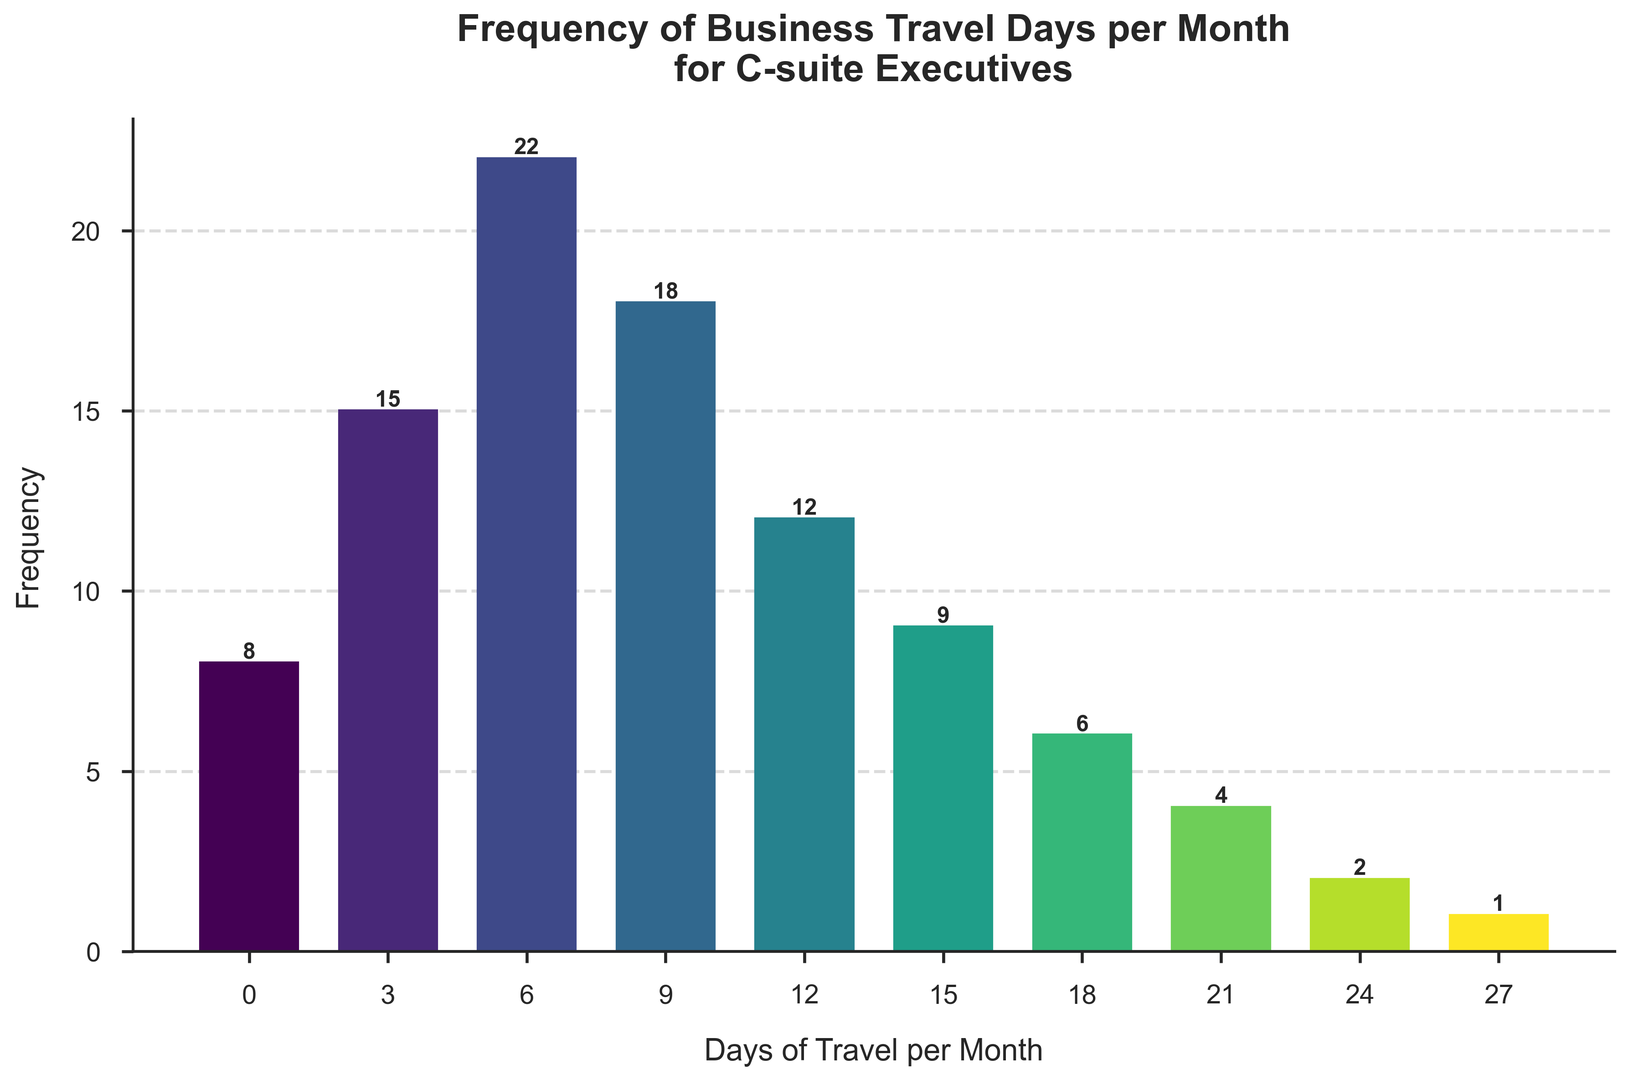What range of days has the highest frequency of business travel? By looking at the height of the bars, the "6-8" range has the tallest bar, indicating the highest frequency.
Answer: 6-8 What is the total frequency of days where business travel is less than 9 days per month? Sum the frequencies of the ranges "0-2," "3-5," and "6-8": 8 + 15 + 22 = 45.
Answer: 45 Compare the frequency of business travel days between the "9-11" and "15-17" ranges. Which is higher? The bar for "9-11" is taller than the bar for "15-17." The respective frequencies are 18 and 9.
Answer: 9-11 What is the combined frequency for the ranges "12-14" and "24-26"? Add the frequencies for "12-14" (12) and "24-26" (2): 12 + 2 = 14.
Answer: 14 Which range of days has the lowest frequency of business travel? The bar for "27-30" is the shortest, and the frequency is 1.
Answer: 27-30 Is the frequency of business travel days in the "0-2" range greater than the "21-23" range? Comparing the heights, the frequency for "0-2" (8) is greater than that for "21-23" (4).
Answer: Yes How many ranges have a frequency greater than 10? The ranges are "3-5," "6-8," "9-11," and "12-14," making a total of 4 ranges.
Answer: 4 What is the average frequency of the ranges "0-2," "3-5," and "6-8"? Sum the frequencies (8 + 15 + 22 = 45) and divide by the number of ranges (3): 45 / 3 = 15.
Answer: 15 Which range has a frequency closest to the median frequency of all the displayed ranges? The frequencies sorted are: 1, 2, 4, 6, 8, 9, 12, 15, 18, 22. The median of these 10 values is the average of the 5th and 6th values: (8 + 9) / 2 = 8.5. The closest range frequency to this is "9-11" with a frequency of 9.
Answer: 9-11 